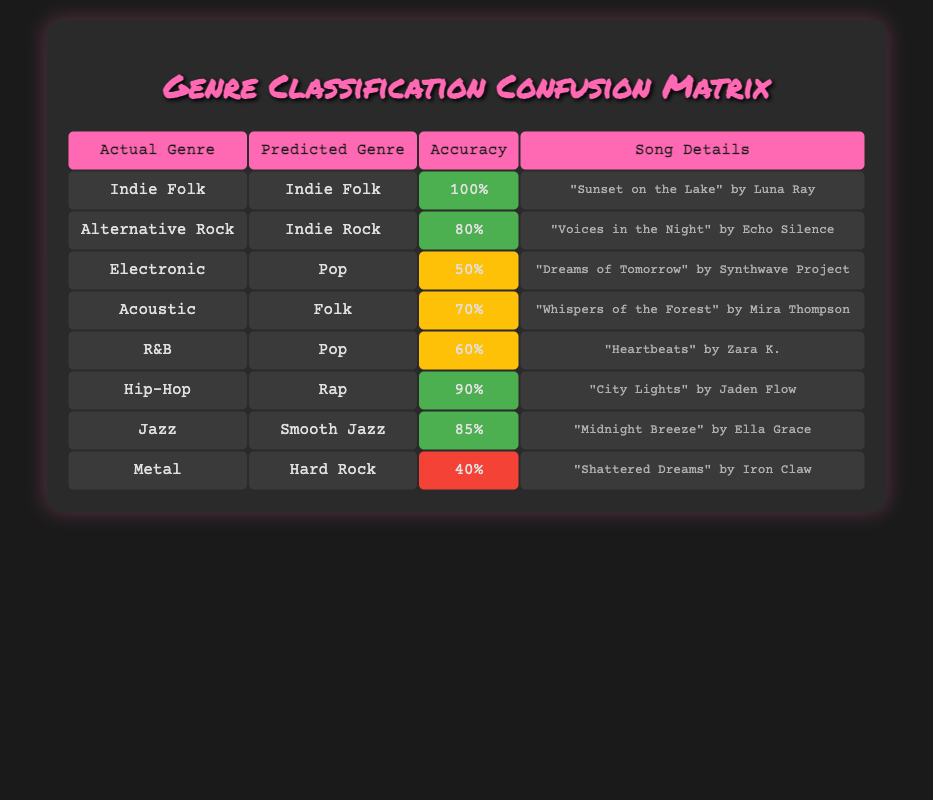What song has the highest accuracy classification? The highest accuracy of classification shown in the table is 100%, which corresponds to "Sunset on the Lake" by Luna Ray, where the actual genre matches the predicted genre.
Answer: Sunset on the Lake How many songs were classified with an accuracy of 70% or higher? There are four songs with an accuracy of 70% or higher, which are "Sunset on the Lake" (100%), "City Lights" (90%), "Midnight Breeze" (85%), and "Voices in the Night" (80%).
Answer: Four Is "Heartbeats" classified accurately as R&B? No, "Heartbeats" is predicted to be Pop, which does not match its actual genre R&B, so it is not classified accurately.
Answer: No What is the difference in accuracy between the song "City Lights" and "Shattered Dreams"? "City Lights" has an accuracy of 90%, and "Shattered Dreams" has an accuracy of 40%. The difference is 90% - 40% = 50%.
Answer: 50% Which genre had the lowest classification accuracy? The genre with the lowest classification accuracy is "Metal," with an accuracy of 40% as predicted for the song "Shattered Dreams."
Answer: Metal 